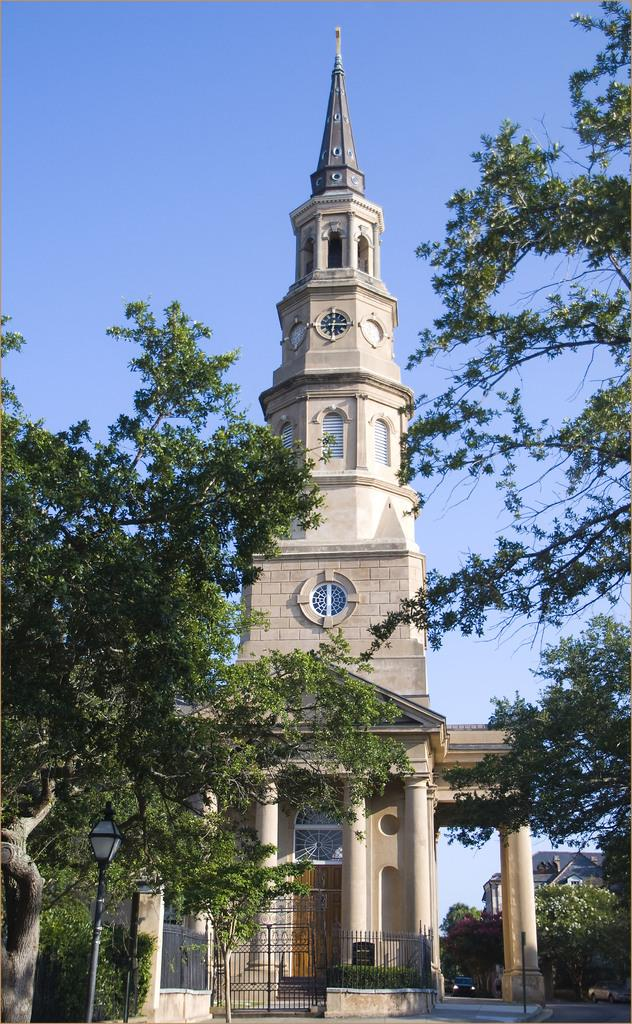What type of natural elements can be seen in the image? There are trees in the image. What type of man-made structures are present in the image? There are buildings in the image. What type of barrier can be seen in the image? There is a fence in the image. What type of living organisms can be seen in the image besides trees? There are plants in the image. What part of the natural environment is visible in the image? The sky is visible in the image. What type of legal advice is the lawyer providing to the brother in the image? There is no lawyer, act, or brother present in the image. 